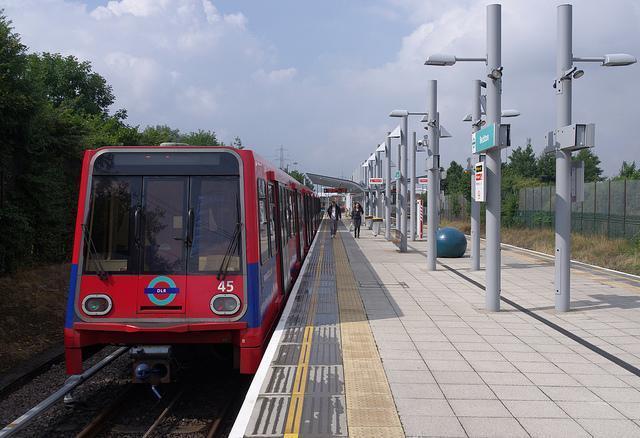How many trains are there?
Give a very brief answer. 1. How many cats are in the picture?
Give a very brief answer. 0. 